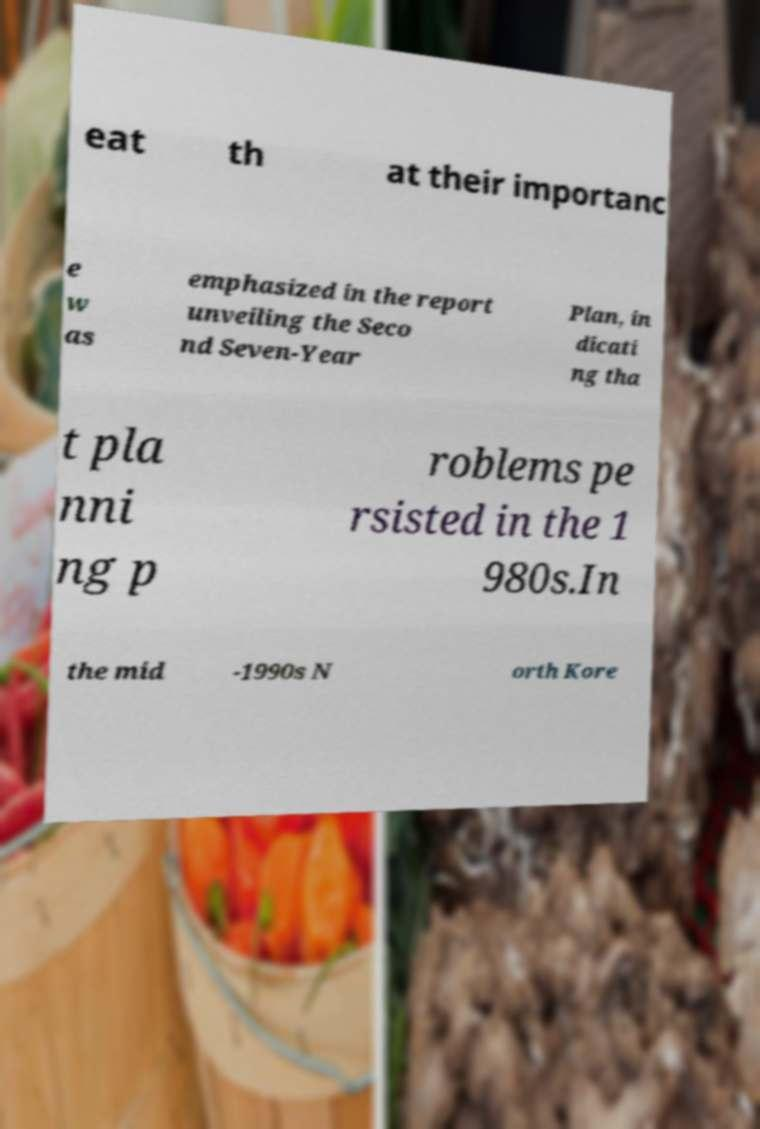Please identify and transcribe the text found in this image. eat th at their importanc e w as emphasized in the report unveiling the Seco nd Seven-Year Plan, in dicati ng tha t pla nni ng p roblems pe rsisted in the 1 980s.In the mid -1990s N orth Kore 